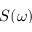<formula> <loc_0><loc_0><loc_500><loc_500>S ( \omega )</formula> 